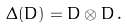Convert formula to latex. <formula><loc_0><loc_0><loc_500><loc_500>\Delta ( D ) = D \otimes D \, .</formula> 